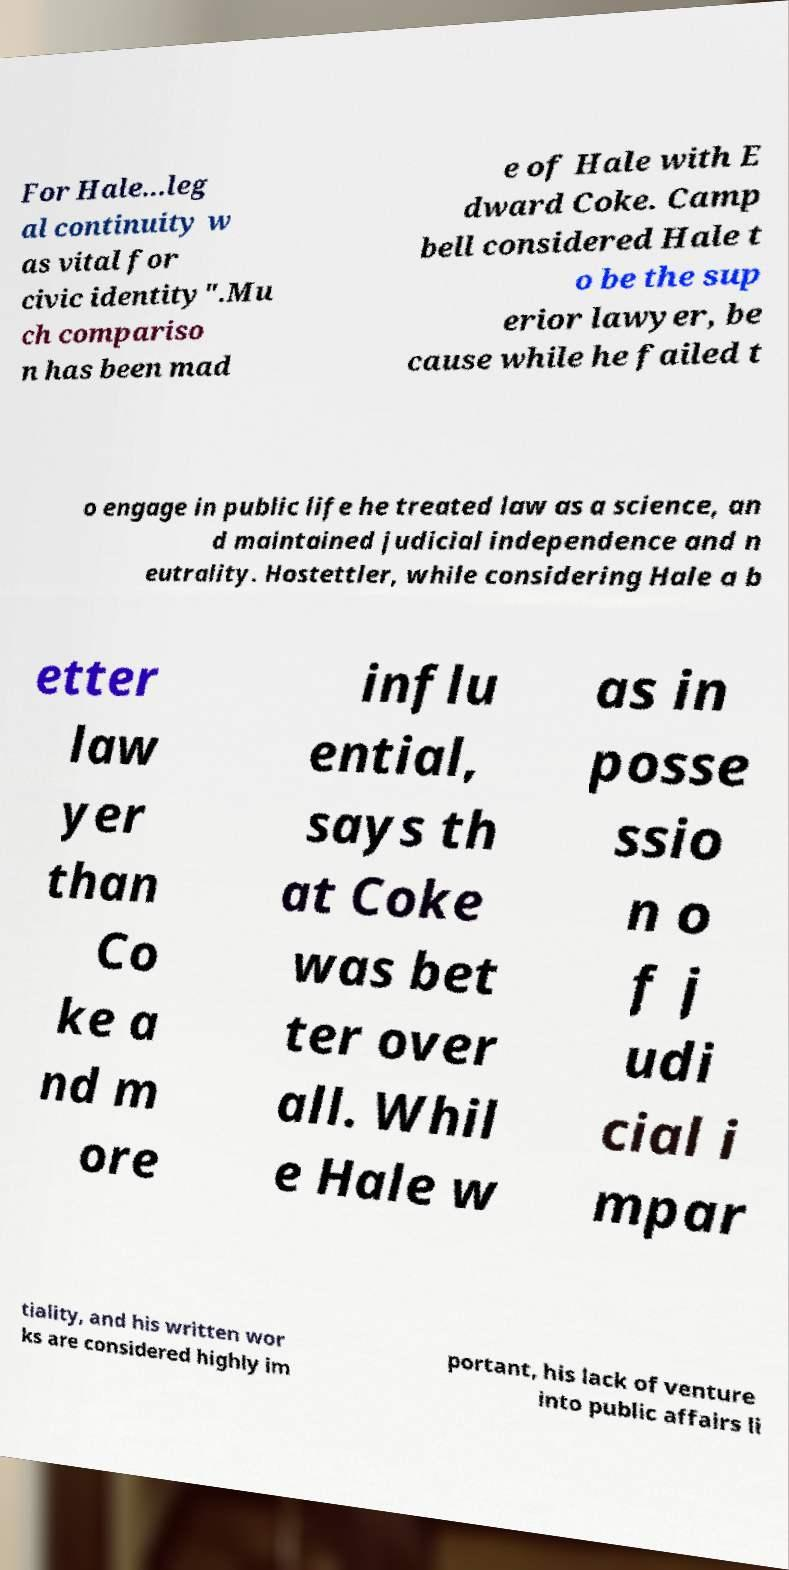There's text embedded in this image that I need extracted. Can you transcribe it verbatim? For Hale...leg al continuity w as vital for civic identity".Mu ch compariso n has been mad e of Hale with E dward Coke. Camp bell considered Hale t o be the sup erior lawyer, be cause while he failed t o engage in public life he treated law as a science, an d maintained judicial independence and n eutrality. Hostettler, while considering Hale a b etter law yer than Co ke a nd m ore influ ential, says th at Coke was bet ter over all. Whil e Hale w as in posse ssio n o f j udi cial i mpar tiality, and his written wor ks are considered highly im portant, his lack of venture into public affairs li 